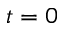Convert formula to latex. <formula><loc_0><loc_0><loc_500><loc_500>t = 0</formula> 